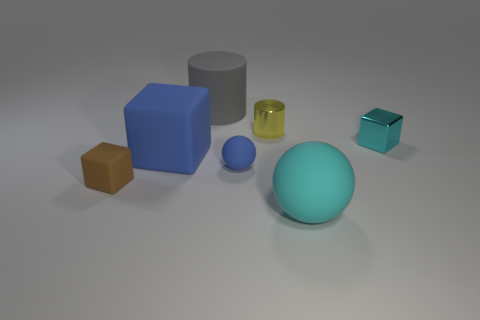Add 1 big cyan things. How many objects exist? 8 Subtract all spheres. How many objects are left? 5 Add 1 tiny matte cubes. How many tiny matte cubes are left? 2 Add 7 gray matte cylinders. How many gray matte cylinders exist? 8 Subtract 0 red balls. How many objects are left? 7 Subtract all big red metal spheres. Subtract all big gray matte objects. How many objects are left? 6 